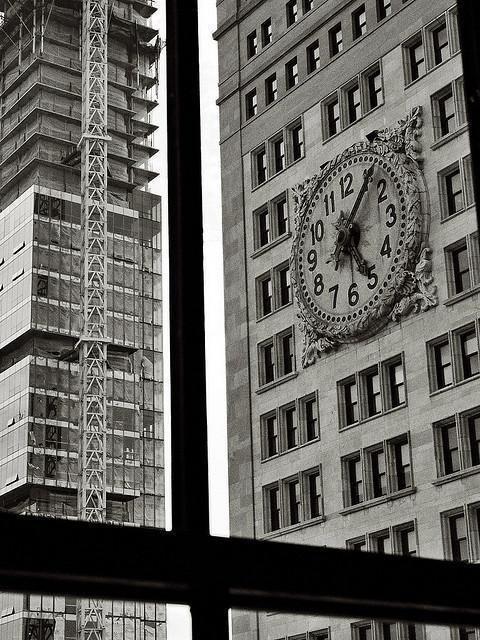How many floors are pictured?
Give a very brief answer. 10. 